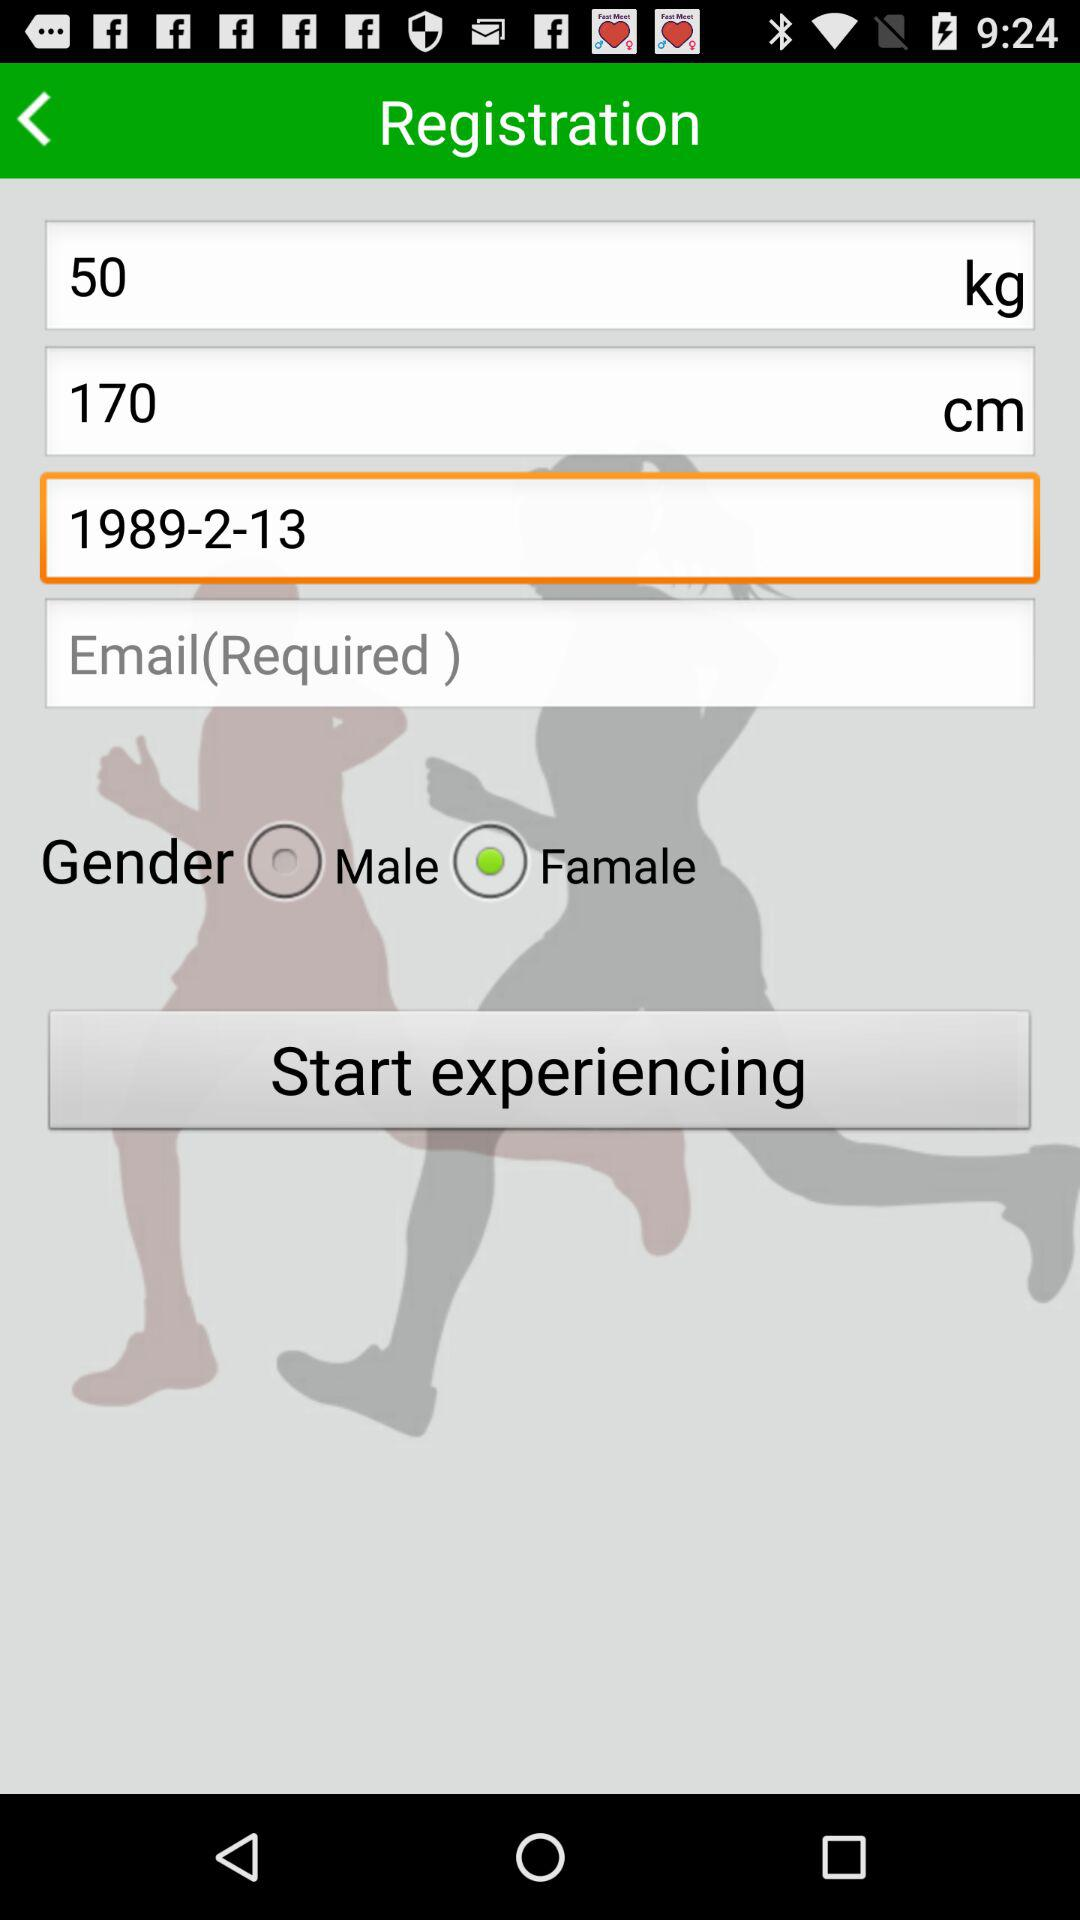What is the mentioned weight? The mentioned weight is 50 kg. 